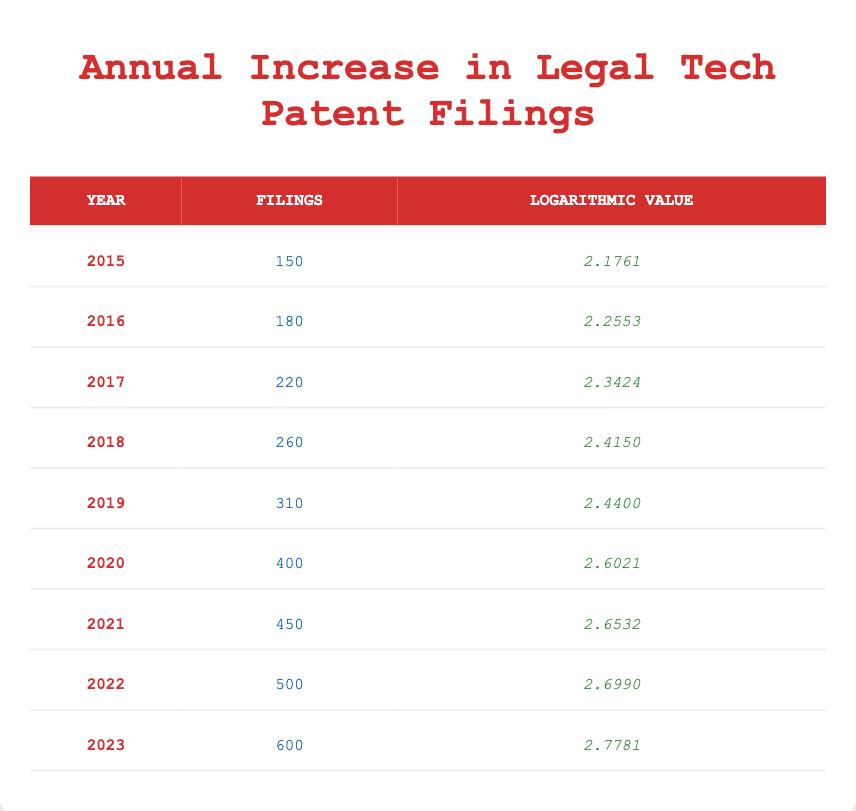What year had the highest number of legal tech patent filings? By examining the "Filings" column in the table, we can see that the year 2023 had the highest number of filings at 600.
Answer: 2023 What was the total number of legal tech patent filings from 2015 to 2023? To find the total filings, we sum the values in the "Filings" column: 150 + 180 + 220 + 260 + 310 + 400 + 450 + 500 + 600 = 2670.
Answer: 2670 Was there an increase in patent filings from 2019 to 2020? In 2019, the filings were 310, and in 2020, they were 400, indicating an increase of 90 filings. Therefore, there was indeed an increase.
Answer: Yes What is the average number of patent filings from 2015 to 2023? There are 9 years of data. We sum the filings (150 + 180 + 220 + 260 + 310 + 400 + 450 + 500 + 600 = 2670) and divide by the number of years (9): 2670 / 9 = 296.67.
Answer: 296.67 How many years had filings greater than 400? Counting the rows with filings over 400, we see that from 2020 to 2023 (4 years), they all had filings greater than 400.
Answer: 4 years In which year did the logarithmic value first exceed 2.5? Checking the "Logarithmic Value" column, we see that the year 2020 is the first instance where the value exceeds 2.5, as it has a logarithmic value of 2.6021.
Answer: 2020 What was the year-on-year increase in patent filings from 2017 to 2018? In 2017, filings were 220, and in 2018, they were 260. The difference (260 - 220) equals 40, indicating an increase of 40 filings from 2017 to 2018.
Answer: 40 Which year had the smallest increase in the number of filings compared to the previous year? By looking closely at the differences between filings from year to year, we find that from 2021 to 2022, the increase was 50 (from 450 to 500). No other year had a smaller increase.
Answer: 50 